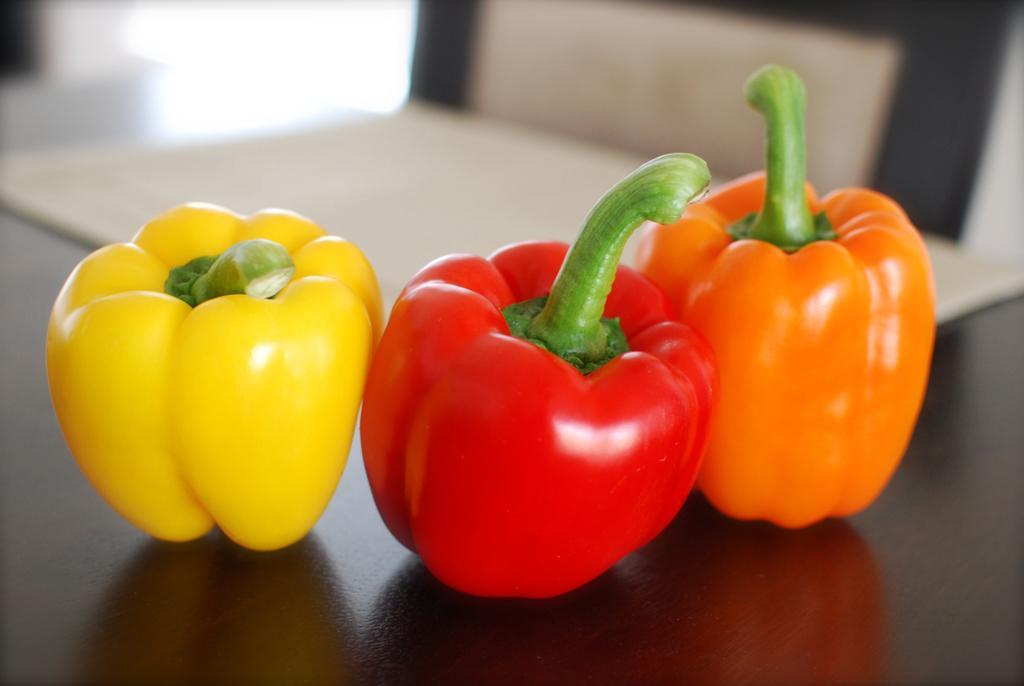Please provide a concise description of this image. As we can see in the image there is a table. On table there are different types of capsicums. 